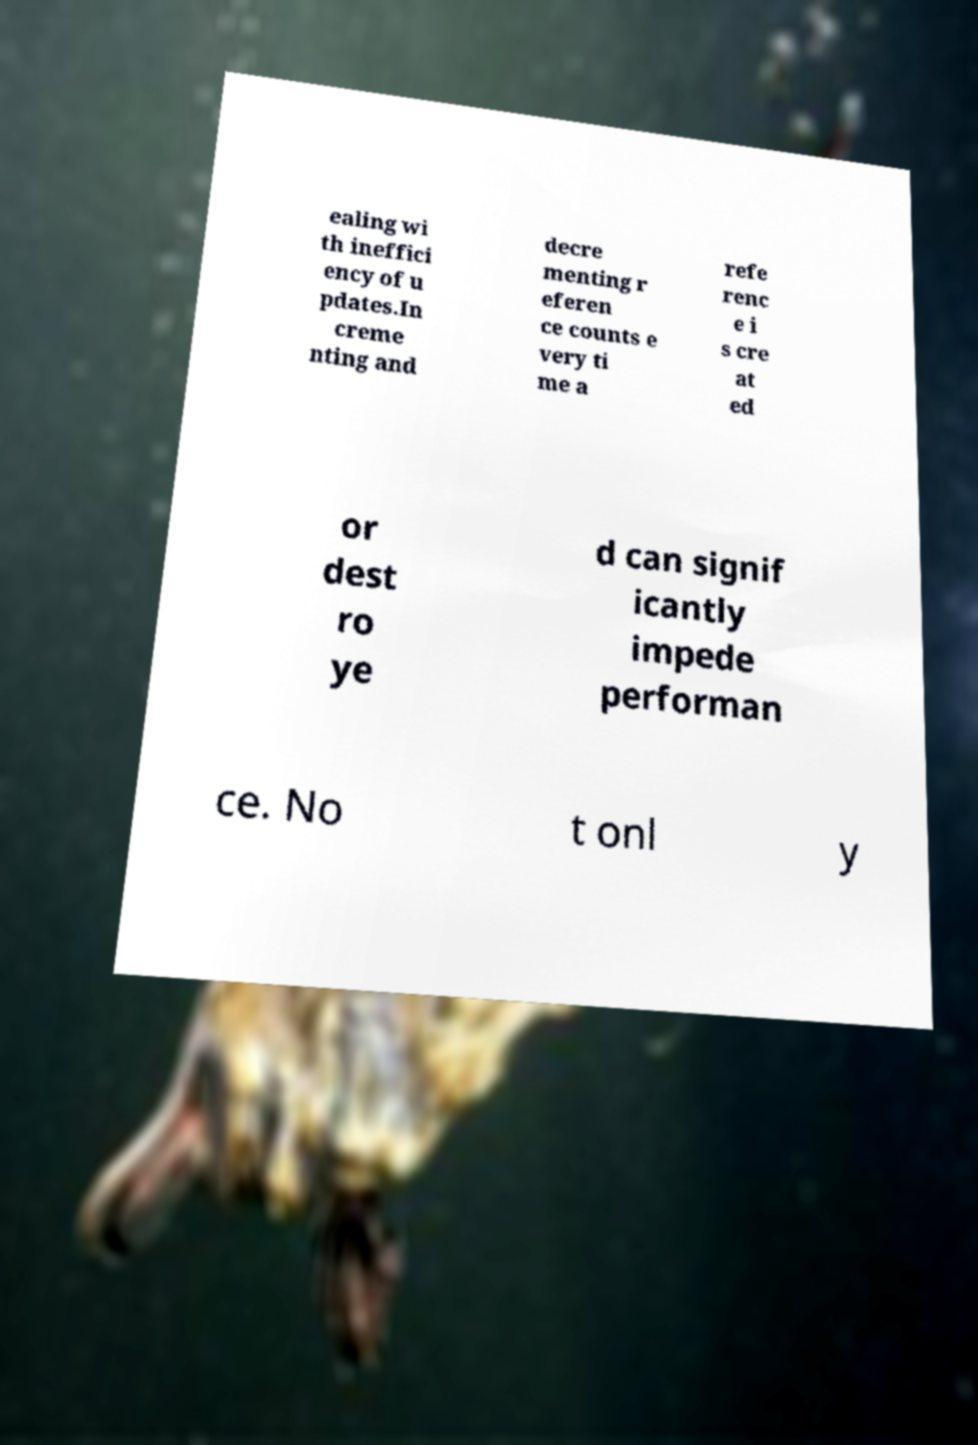Could you assist in decoding the text presented in this image and type it out clearly? ealing wi th ineffici ency of u pdates.In creme nting and decre menting r eferen ce counts e very ti me a refe renc e i s cre at ed or dest ro ye d can signif icantly impede performan ce. No t onl y 